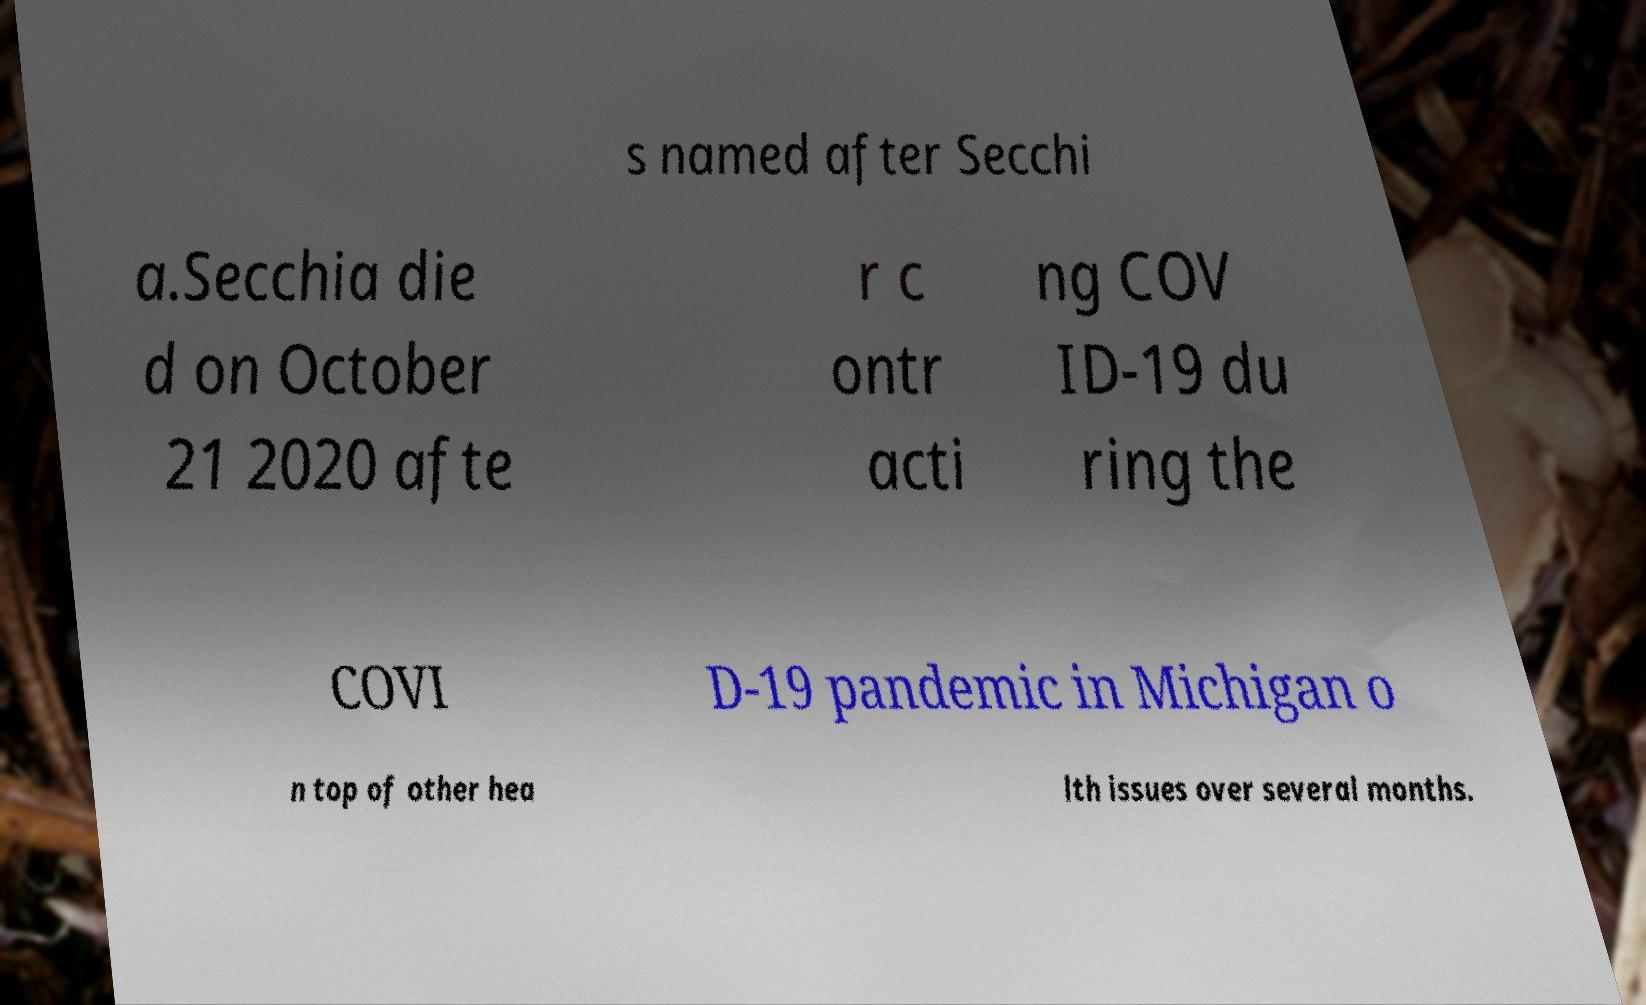Could you assist in decoding the text presented in this image and type it out clearly? s named after Secchi a.Secchia die d on October 21 2020 afte r c ontr acti ng COV ID-19 du ring the COVI D-19 pandemic in Michigan o n top of other hea lth issues over several months. 